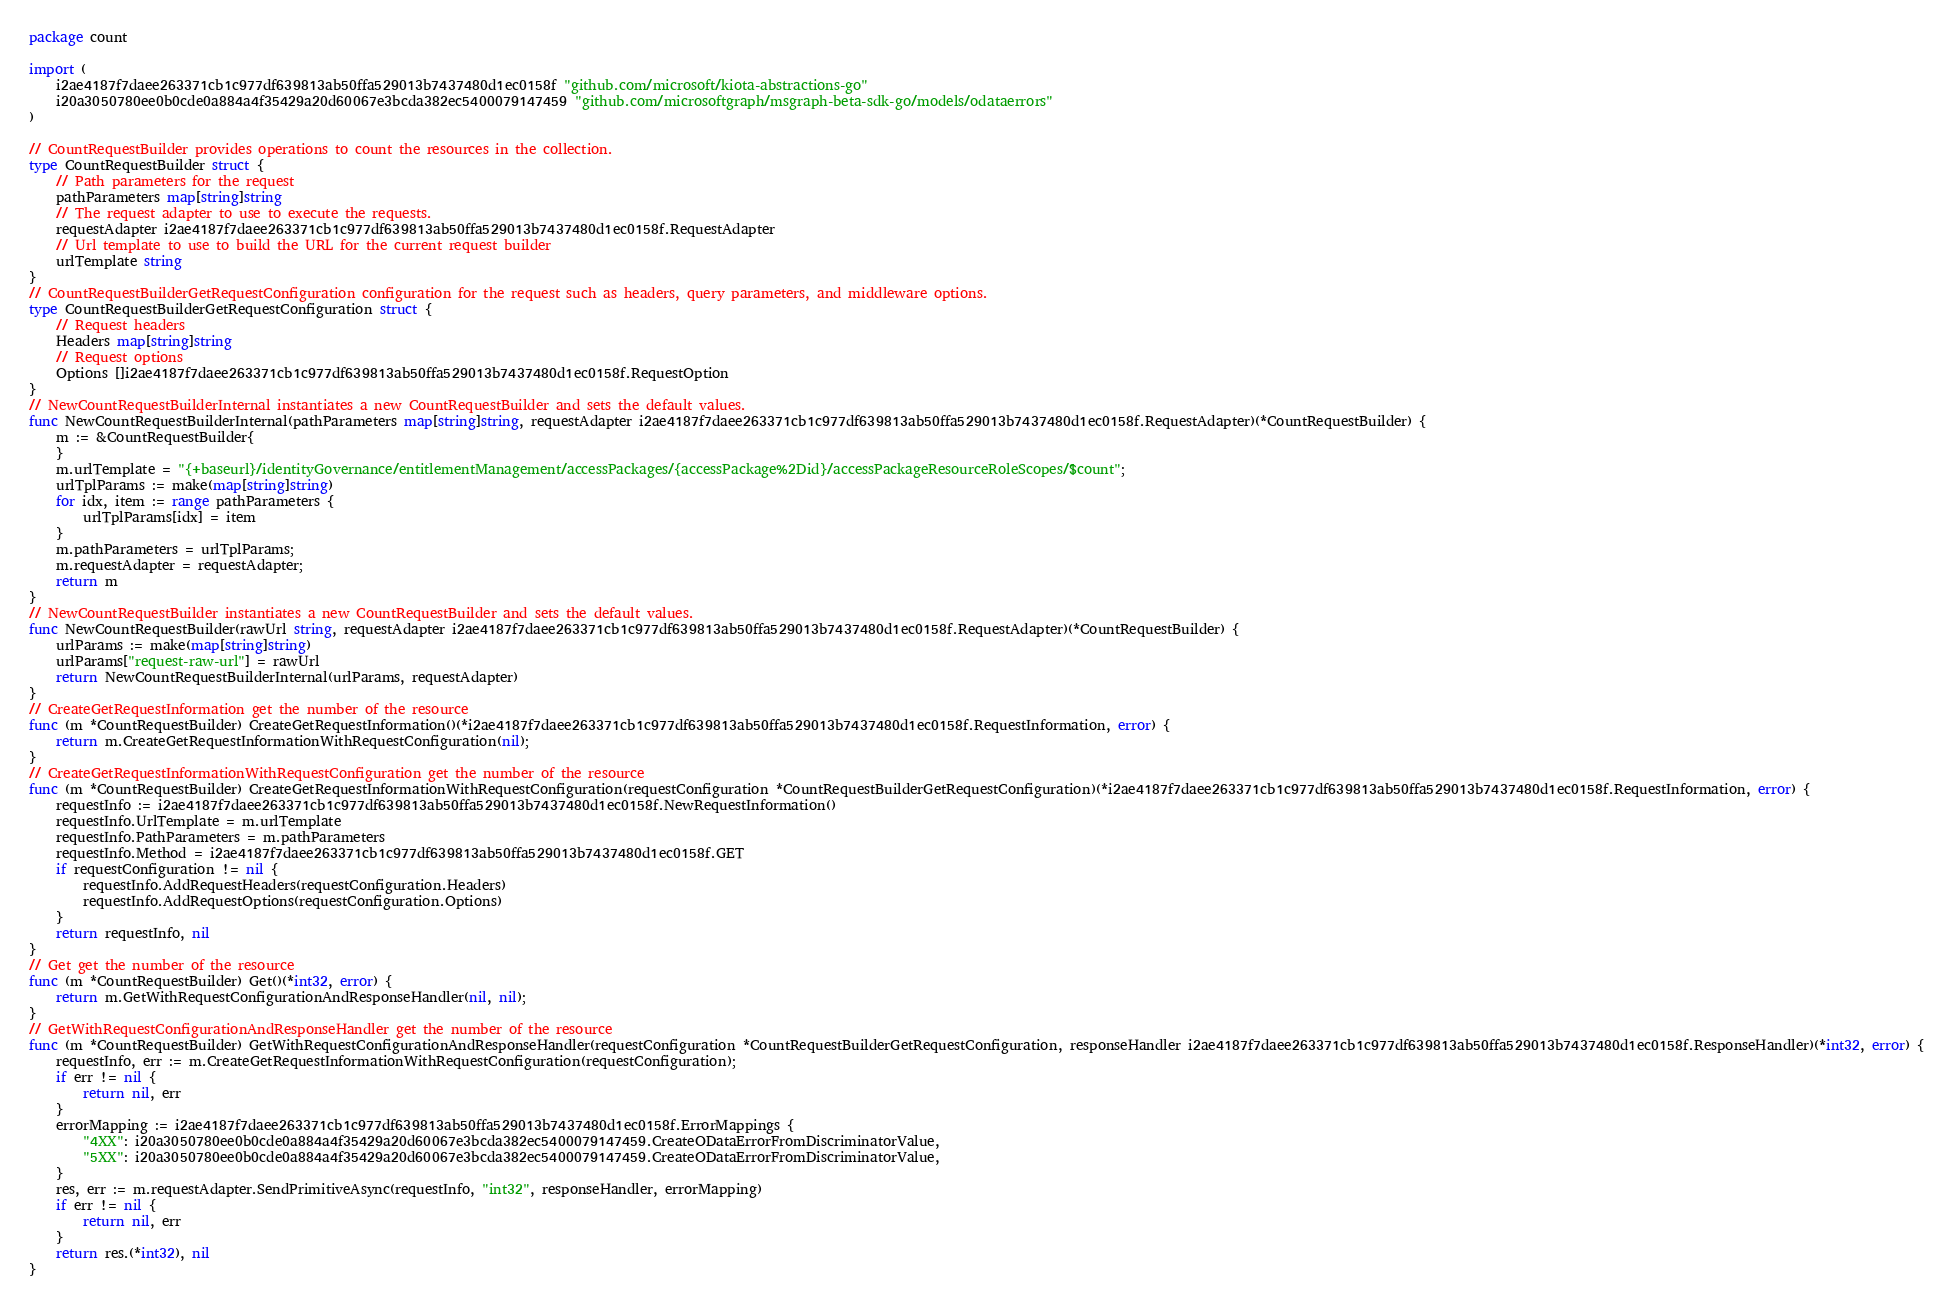Convert code to text. <code><loc_0><loc_0><loc_500><loc_500><_Go_>package count

import (
    i2ae4187f7daee263371cb1c977df639813ab50ffa529013b7437480d1ec0158f "github.com/microsoft/kiota-abstractions-go"
    i20a3050780ee0b0cde0a884a4f35429a20d60067e3bcda382ec5400079147459 "github.com/microsoftgraph/msgraph-beta-sdk-go/models/odataerrors"
)

// CountRequestBuilder provides operations to count the resources in the collection.
type CountRequestBuilder struct {
    // Path parameters for the request
    pathParameters map[string]string
    // The request adapter to use to execute the requests.
    requestAdapter i2ae4187f7daee263371cb1c977df639813ab50ffa529013b7437480d1ec0158f.RequestAdapter
    // Url template to use to build the URL for the current request builder
    urlTemplate string
}
// CountRequestBuilderGetRequestConfiguration configuration for the request such as headers, query parameters, and middleware options.
type CountRequestBuilderGetRequestConfiguration struct {
    // Request headers
    Headers map[string]string
    // Request options
    Options []i2ae4187f7daee263371cb1c977df639813ab50ffa529013b7437480d1ec0158f.RequestOption
}
// NewCountRequestBuilderInternal instantiates a new CountRequestBuilder and sets the default values.
func NewCountRequestBuilderInternal(pathParameters map[string]string, requestAdapter i2ae4187f7daee263371cb1c977df639813ab50ffa529013b7437480d1ec0158f.RequestAdapter)(*CountRequestBuilder) {
    m := &CountRequestBuilder{
    }
    m.urlTemplate = "{+baseurl}/identityGovernance/entitlementManagement/accessPackages/{accessPackage%2Did}/accessPackageResourceRoleScopes/$count";
    urlTplParams := make(map[string]string)
    for idx, item := range pathParameters {
        urlTplParams[idx] = item
    }
    m.pathParameters = urlTplParams;
    m.requestAdapter = requestAdapter;
    return m
}
// NewCountRequestBuilder instantiates a new CountRequestBuilder and sets the default values.
func NewCountRequestBuilder(rawUrl string, requestAdapter i2ae4187f7daee263371cb1c977df639813ab50ffa529013b7437480d1ec0158f.RequestAdapter)(*CountRequestBuilder) {
    urlParams := make(map[string]string)
    urlParams["request-raw-url"] = rawUrl
    return NewCountRequestBuilderInternal(urlParams, requestAdapter)
}
// CreateGetRequestInformation get the number of the resource
func (m *CountRequestBuilder) CreateGetRequestInformation()(*i2ae4187f7daee263371cb1c977df639813ab50ffa529013b7437480d1ec0158f.RequestInformation, error) {
    return m.CreateGetRequestInformationWithRequestConfiguration(nil);
}
// CreateGetRequestInformationWithRequestConfiguration get the number of the resource
func (m *CountRequestBuilder) CreateGetRequestInformationWithRequestConfiguration(requestConfiguration *CountRequestBuilderGetRequestConfiguration)(*i2ae4187f7daee263371cb1c977df639813ab50ffa529013b7437480d1ec0158f.RequestInformation, error) {
    requestInfo := i2ae4187f7daee263371cb1c977df639813ab50ffa529013b7437480d1ec0158f.NewRequestInformation()
    requestInfo.UrlTemplate = m.urlTemplate
    requestInfo.PathParameters = m.pathParameters
    requestInfo.Method = i2ae4187f7daee263371cb1c977df639813ab50ffa529013b7437480d1ec0158f.GET
    if requestConfiguration != nil {
        requestInfo.AddRequestHeaders(requestConfiguration.Headers)
        requestInfo.AddRequestOptions(requestConfiguration.Options)
    }
    return requestInfo, nil
}
// Get get the number of the resource
func (m *CountRequestBuilder) Get()(*int32, error) {
    return m.GetWithRequestConfigurationAndResponseHandler(nil, nil);
}
// GetWithRequestConfigurationAndResponseHandler get the number of the resource
func (m *CountRequestBuilder) GetWithRequestConfigurationAndResponseHandler(requestConfiguration *CountRequestBuilderGetRequestConfiguration, responseHandler i2ae4187f7daee263371cb1c977df639813ab50ffa529013b7437480d1ec0158f.ResponseHandler)(*int32, error) {
    requestInfo, err := m.CreateGetRequestInformationWithRequestConfiguration(requestConfiguration);
    if err != nil {
        return nil, err
    }
    errorMapping := i2ae4187f7daee263371cb1c977df639813ab50ffa529013b7437480d1ec0158f.ErrorMappings {
        "4XX": i20a3050780ee0b0cde0a884a4f35429a20d60067e3bcda382ec5400079147459.CreateODataErrorFromDiscriminatorValue,
        "5XX": i20a3050780ee0b0cde0a884a4f35429a20d60067e3bcda382ec5400079147459.CreateODataErrorFromDiscriminatorValue,
    }
    res, err := m.requestAdapter.SendPrimitiveAsync(requestInfo, "int32", responseHandler, errorMapping)
    if err != nil {
        return nil, err
    }
    return res.(*int32), nil
}
</code> 